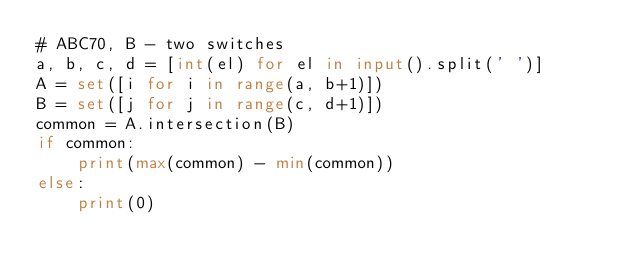<code> <loc_0><loc_0><loc_500><loc_500><_Python_># ABC70, B - two switches
a, b, c, d = [int(el) for el in input().split(' ')]
A = set([i for i in range(a, b+1)])
B = set([j for j in range(c, d+1)])
common = A.intersection(B)
if common:
    print(max(common) - min(common))
else:
    print(0)
</code> 